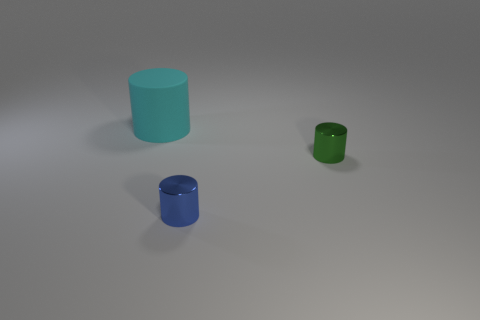Is there a small blue cylinder that has the same material as the small blue thing?
Make the answer very short. No. How many cyan objects are either big objects or small metallic cylinders?
Make the answer very short. 1. How big is the cylinder that is both in front of the matte cylinder and on the left side of the small green object?
Offer a terse response. Small. Is the number of objects to the left of the blue metallic thing greater than the number of tiny purple objects?
Your answer should be very brief. Yes. How many cubes are tiny green things or blue objects?
Keep it short and to the point. 0. The object that is in front of the big rubber cylinder and behind the small blue shiny cylinder has what shape?
Your answer should be compact. Cylinder. Are there the same number of large rubber objects to the right of the big rubber cylinder and tiny blue things that are to the left of the green thing?
Provide a short and direct response. No. What number of objects are either big cylinders or blue cylinders?
Give a very brief answer. 2. There is a shiny object that is the same size as the green cylinder; what is its color?
Keep it short and to the point. Blue. How many objects are metallic objects behind the blue metal thing or objects that are in front of the small green metallic cylinder?
Provide a succinct answer. 2. 